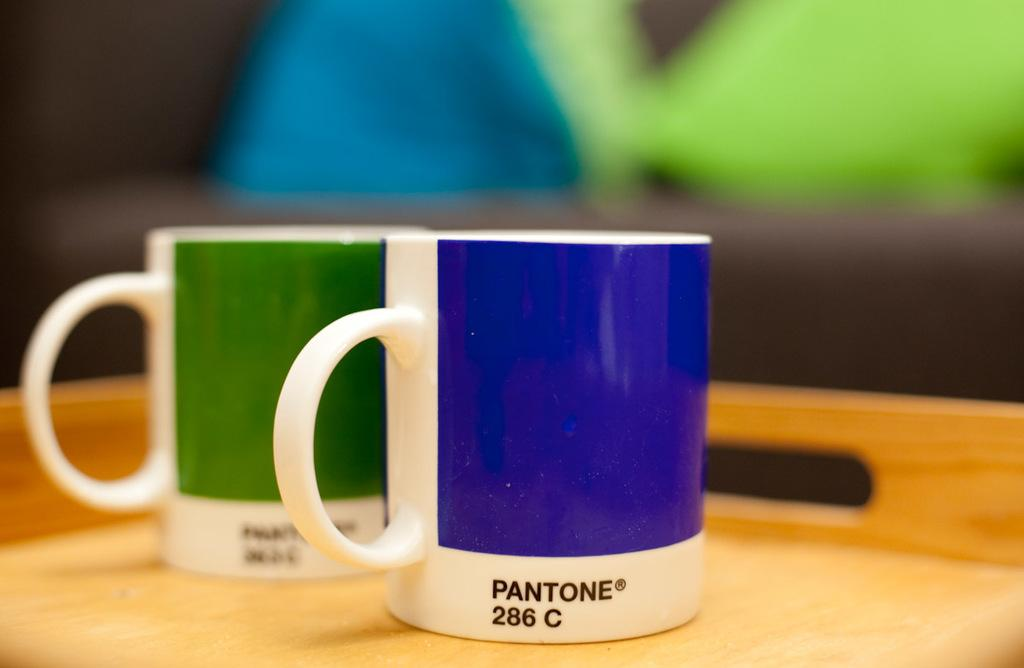Provide a one-sentence caption for the provided image. A blue mug with Pantone 286C sits next to a green mug that also has a Pantone label. 